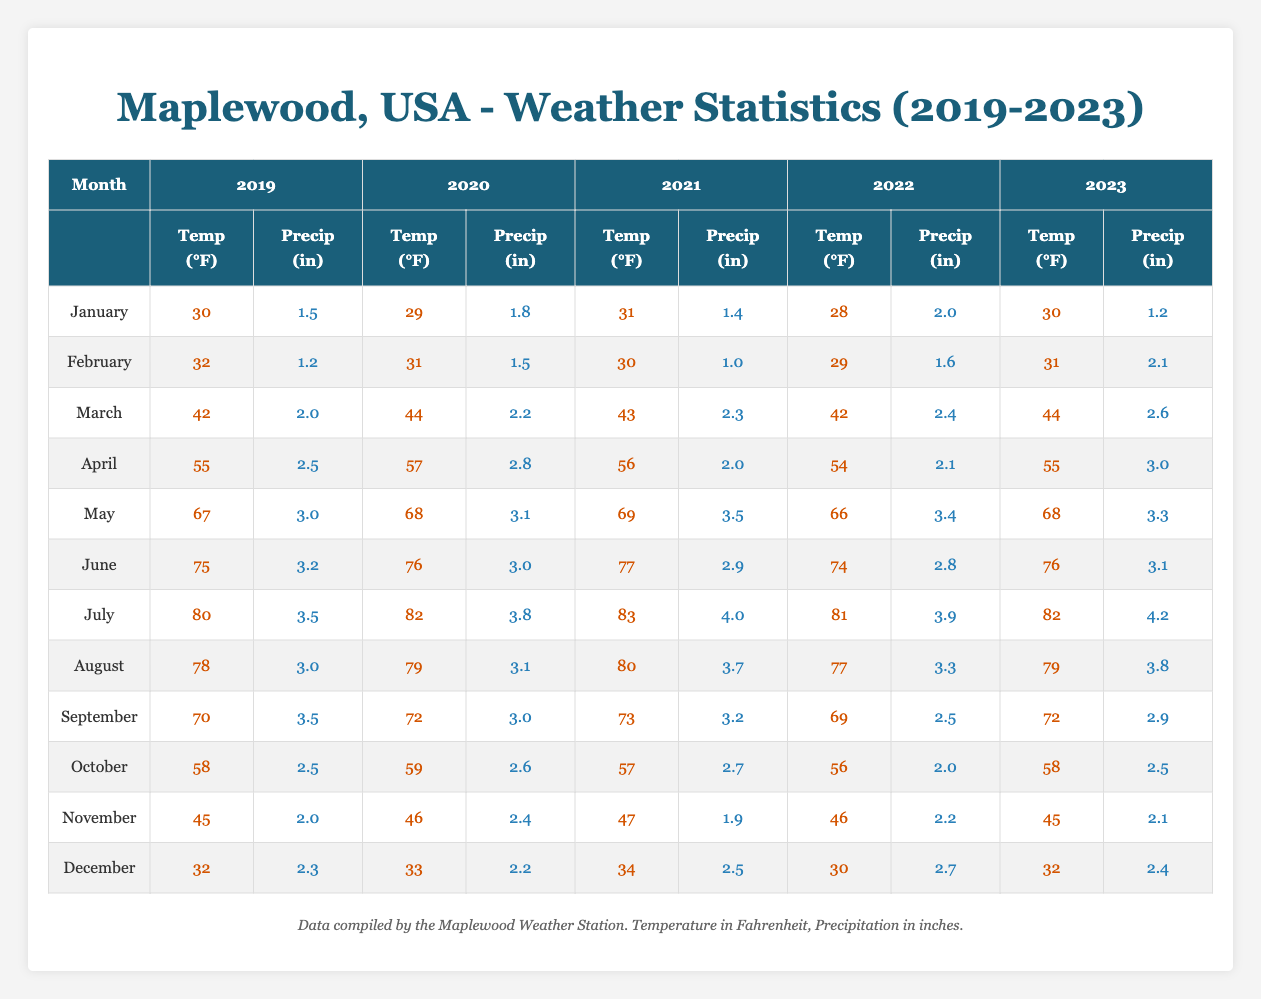What was the average temperature in July over the five years? To find the average temperature in July, we take the temperatures from each year (80 for 2019, 82 for 2020, 83 for 2021, 81 for 2022, and 82 for 2023), sum them up: (80 + 82 + 83 + 81 + 82) = 408. We then divide by the number of years, which is 5: 408 / 5 = 81.6.
Answer: 81.6 Which year had the highest average precipitation in December? We compare the precipitation for December across the five years: 2.3 inches in 2019, 2.2 in 2020, 2.5 in 2021, 2.7 in 2022, and 2.4 in 2023. We see that the highest value is 2.7 inches in 2022.
Answer: 2022 Was the average temperature in March consistently higher than 40°F from 2019 to 2023? We check the temperatures for March each year: 42 in 2019, 44 in 2020, 43 in 2021, 42 in 2022, and 44 in 2023. Each of these values is greater than 40°F, so the average temperature was consistently higher.
Answer: Yes In which month of 2021 was the precipitation level the lowest? By reviewing the precipitation for each month in 2021: January 1.4, February 1.0, March 2.3, April 2.0, May 3.5, June 2.9, July 4.0, August 3.7, September 3.2, October 2.7, November 1.9, December 2.5, we see that February had the lowest at 1.0 inches.
Answer: February What was the trend in average temperatures from May to July over the five years? We examine the average temperatures for May, June, and July for each year: May (67°F to 68°F), June (75°F to 76°F), and July (80°F to 82°F). The temperatures increased each month, indicating a consistent upward trend.
Answer: Increasing Was there a year when the average precipitation in August exceeded 3 inches? Reviewing the precipitation for August: 3.0 inches in 2019, 3.1 in 2020, 3.7 in 2021, 3.3 in 2022, and 3.8 in 2023 confirms that 2021 and 2023 both exceeded 3 inches.
Answer: Yes What is the total precipitation recorded in the month of October over the five years? To calculate the total precipitation for October: 2.5 for 2019, 2.6 for 2020, 2.7 for 2021, 2.0 for 2022, and 2.5 for 2023. We sum these values: 2.5 + 2.6 + 2.7 + 2.0 + 2.5 = 12.3 inches.
Answer: 12.3 inches 